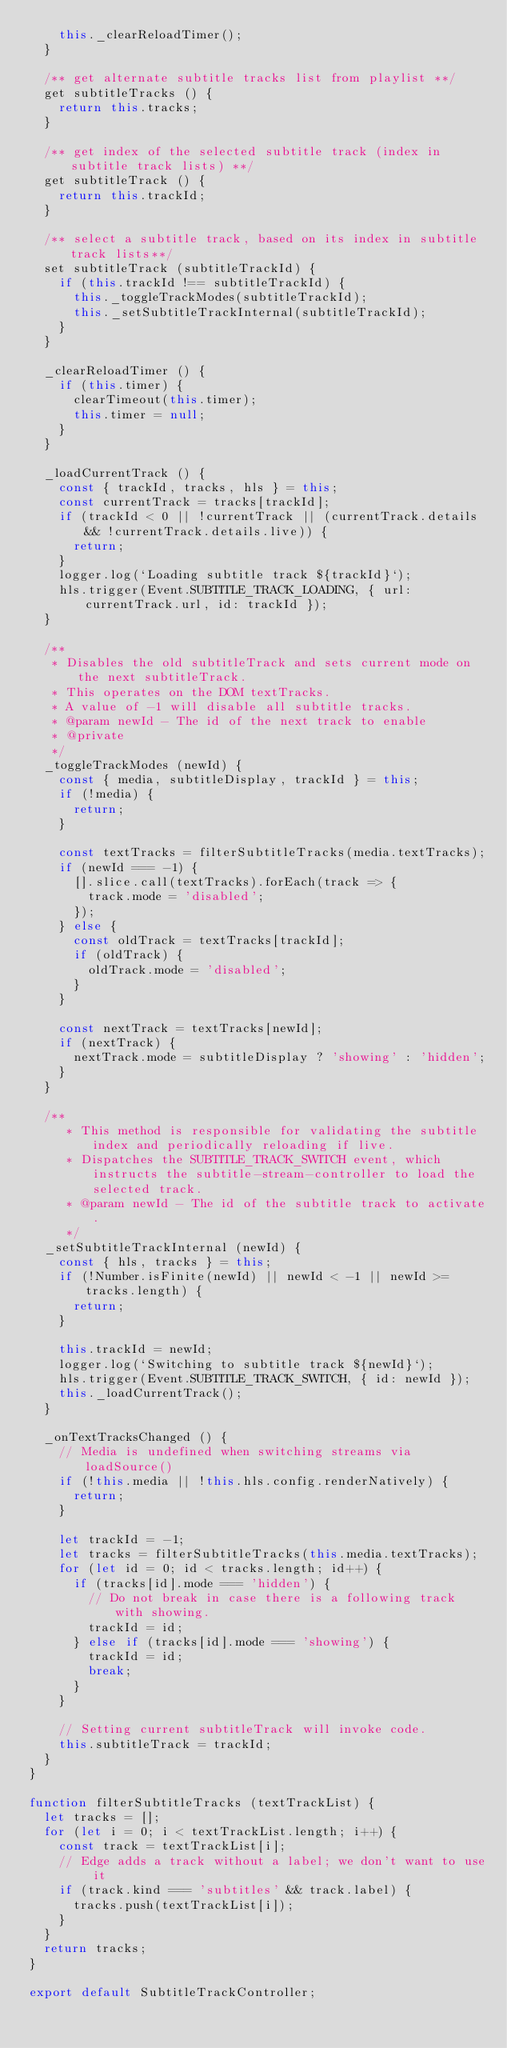Convert code to text. <code><loc_0><loc_0><loc_500><loc_500><_JavaScript_>    this._clearReloadTimer();
  }

  /** get alternate subtitle tracks list from playlist **/
  get subtitleTracks () {
    return this.tracks;
  }

  /** get index of the selected subtitle track (index in subtitle track lists) **/
  get subtitleTrack () {
    return this.trackId;
  }

  /** select a subtitle track, based on its index in subtitle track lists**/
  set subtitleTrack (subtitleTrackId) {
    if (this.trackId !== subtitleTrackId) {
      this._toggleTrackModes(subtitleTrackId);
      this._setSubtitleTrackInternal(subtitleTrackId);
    }
  }

  _clearReloadTimer () {
    if (this.timer) {
      clearTimeout(this.timer);
      this.timer = null;
    }
  }

  _loadCurrentTrack () {
    const { trackId, tracks, hls } = this;
    const currentTrack = tracks[trackId];
    if (trackId < 0 || !currentTrack || (currentTrack.details && !currentTrack.details.live)) {
      return;
    }
    logger.log(`Loading subtitle track ${trackId}`);
    hls.trigger(Event.SUBTITLE_TRACK_LOADING, { url: currentTrack.url, id: trackId });
  }

  /**
   * Disables the old subtitleTrack and sets current mode on the next subtitleTrack.
   * This operates on the DOM textTracks.
   * A value of -1 will disable all subtitle tracks.
   * @param newId - The id of the next track to enable
   * @private
   */
  _toggleTrackModes (newId) {
    const { media, subtitleDisplay, trackId } = this;
    if (!media) {
      return;
    }

    const textTracks = filterSubtitleTracks(media.textTracks);
    if (newId === -1) {
      [].slice.call(textTracks).forEach(track => {
        track.mode = 'disabled';
      });
    } else {
      const oldTrack = textTracks[trackId];
      if (oldTrack) {
        oldTrack.mode = 'disabled';
      }
    }

    const nextTrack = textTracks[newId];
    if (nextTrack) {
      nextTrack.mode = subtitleDisplay ? 'showing' : 'hidden';
    }
  }

  /**
     * This method is responsible for validating the subtitle index and periodically reloading if live.
     * Dispatches the SUBTITLE_TRACK_SWITCH event, which instructs the subtitle-stream-controller to load the selected track.
     * @param newId - The id of the subtitle track to activate.
     */
  _setSubtitleTrackInternal (newId) {
    const { hls, tracks } = this;
    if (!Number.isFinite(newId) || newId < -1 || newId >= tracks.length) {
      return;
    }

    this.trackId = newId;
    logger.log(`Switching to subtitle track ${newId}`);
    hls.trigger(Event.SUBTITLE_TRACK_SWITCH, { id: newId });
    this._loadCurrentTrack();
  }

  _onTextTracksChanged () {
    // Media is undefined when switching streams via loadSource()
    if (!this.media || !this.hls.config.renderNatively) {
      return;
    }

    let trackId = -1;
    let tracks = filterSubtitleTracks(this.media.textTracks);
    for (let id = 0; id < tracks.length; id++) {
      if (tracks[id].mode === 'hidden') {
        // Do not break in case there is a following track with showing.
        trackId = id;
      } else if (tracks[id].mode === 'showing') {
        trackId = id;
        break;
      }
    }

    // Setting current subtitleTrack will invoke code.
    this.subtitleTrack = trackId;
  }
}

function filterSubtitleTracks (textTrackList) {
  let tracks = [];
  for (let i = 0; i < textTrackList.length; i++) {
    const track = textTrackList[i];
    // Edge adds a track without a label; we don't want to use it
    if (track.kind === 'subtitles' && track.label) {
      tracks.push(textTrackList[i]);
    }
  }
  return tracks;
}

export default SubtitleTrackController;
</code> 